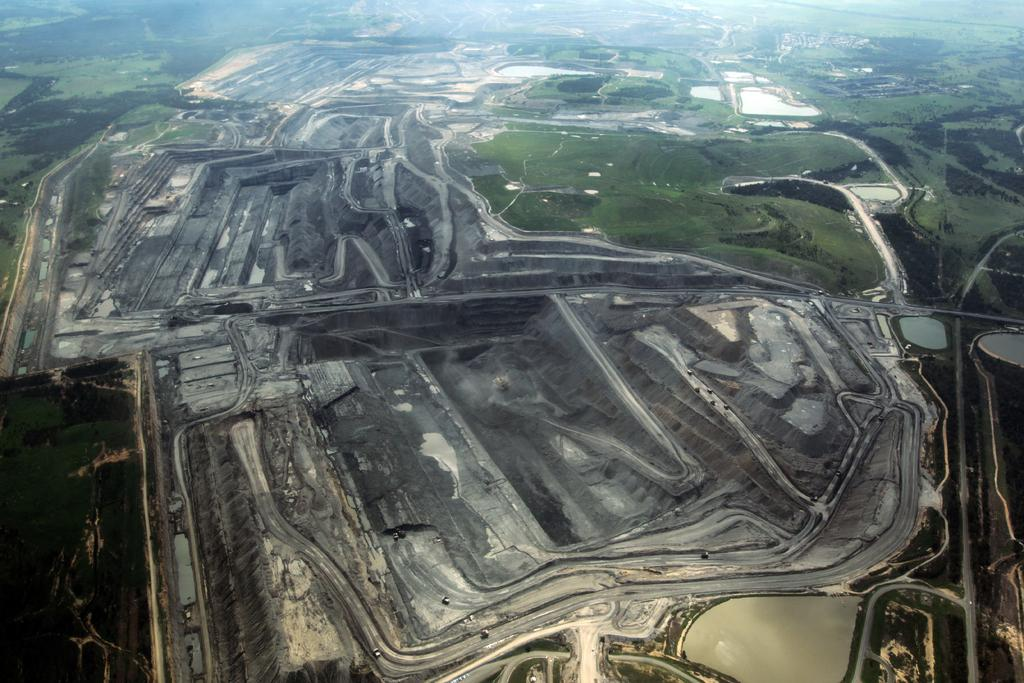What type of view is shown in the image? The image is an aerial view. What can be seen in the image that is related to mining? There are coal mines visible in the image. What feature is present that might be used for transportation? There is a path visible in the image. What type of natural environment is present in the image? Greenery is present in the image. What type of natural resource is visible in the image? There is water visible in the image. What type of apparatus is used for biking in the image? There is no bike or apparatus for biking present in the image. What type of metal is visible in the image? There is no metal visible in the image. 